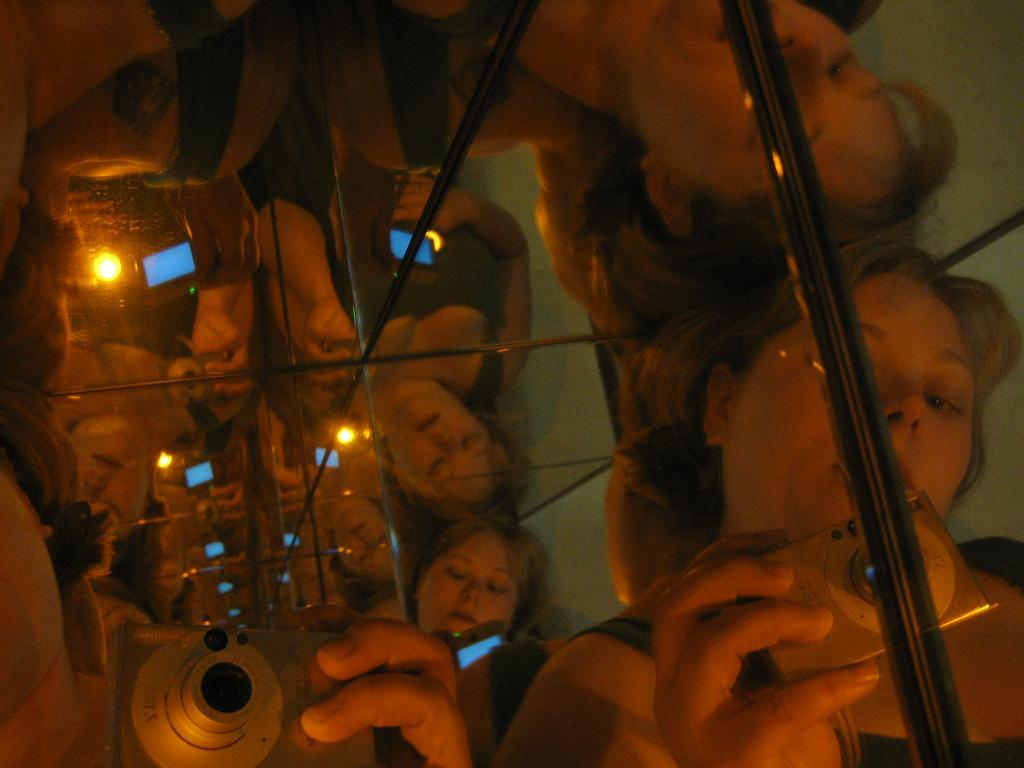Where was the image taken? The image was taken indoors. How would you describe the quality of the image? The image is blurred. Can you identify any person in the image? Yes, there is a woman in the image. What is the woman holding in her hand? The woman is holding a camera in her hand. What type of advice can be seen written on the wall in the image? There is no advice written on the wall in the image; it is not present. 